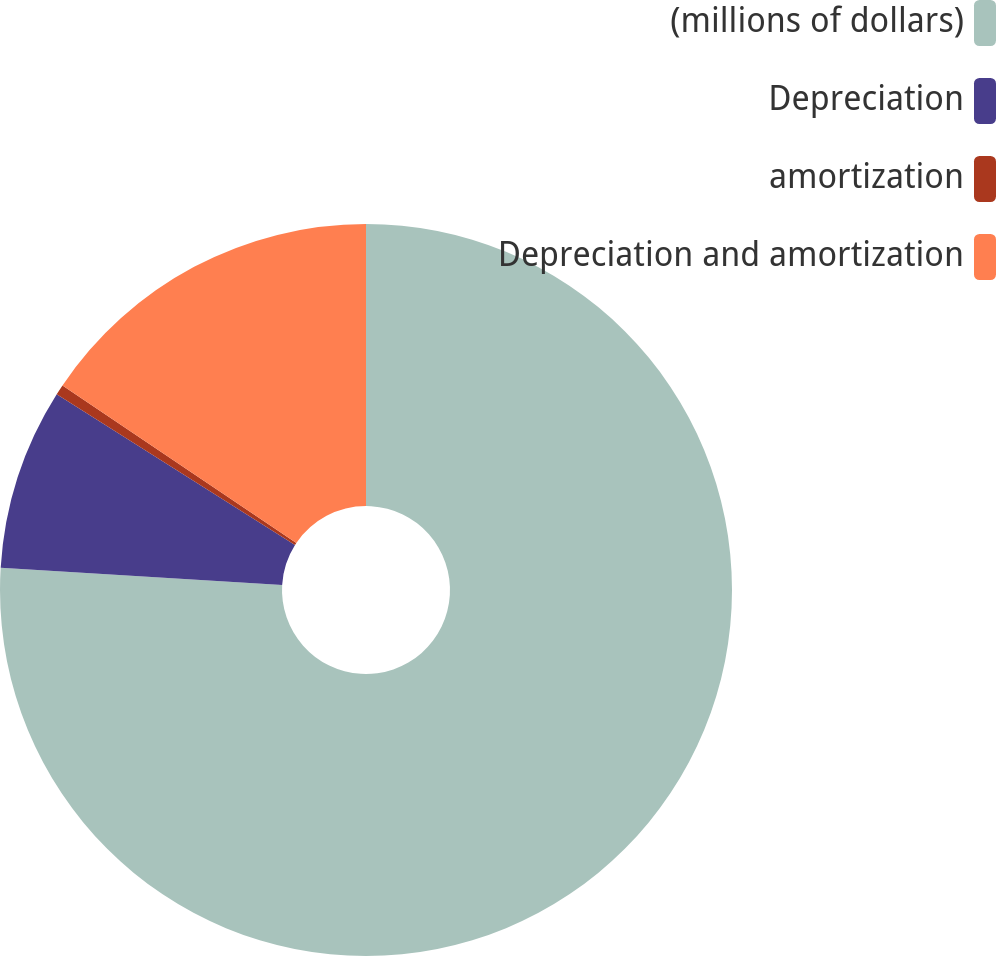Convert chart to OTSL. <chart><loc_0><loc_0><loc_500><loc_500><pie_chart><fcel>(millions of dollars)<fcel>Depreciation<fcel>amortization<fcel>Depreciation and amortization<nl><fcel>75.96%<fcel>8.01%<fcel>0.46%<fcel>15.56%<nl></chart> 